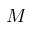Convert formula to latex. <formula><loc_0><loc_0><loc_500><loc_500>M</formula> 